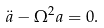<formula> <loc_0><loc_0><loc_500><loc_500>\ddot { a } - \Omega ^ { 2 } a = 0 .</formula> 